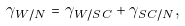<formula> <loc_0><loc_0><loc_500><loc_500>\gamma _ { W / N } = \gamma _ { W / S C } + \gamma _ { S C / N } ,</formula> 